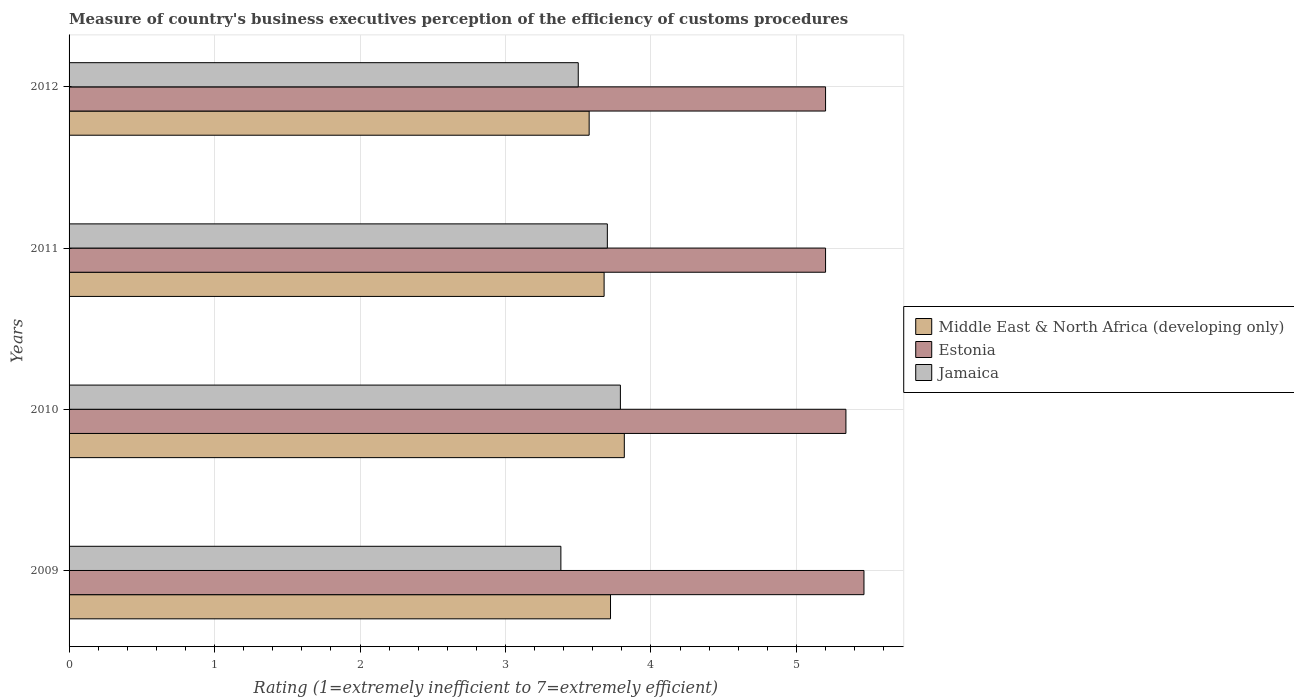How many different coloured bars are there?
Your answer should be compact. 3. How many groups of bars are there?
Provide a succinct answer. 4. Are the number of bars per tick equal to the number of legend labels?
Make the answer very short. Yes. How many bars are there on the 1st tick from the bottom?
Your response must be concise. 3. What is the rating of the efficiency of customs procedure in Jamaica in 2011?
Provide a short and direct response. 3.7. Across all years, what is the maximum rating of the efficiency of customs procedure in Jamaica?
Your answer should be very brief. 3.79. Across all years, what is the minimum rating of the efficiency of customs procedure in Estonia?
Keep it short and to the point. 5.2. In which year was the rating of the efficiency of customs procedure in Middle East & North Africa (developing only) maximum?
Your answer should be very brief. 2010. What is the total rating of the efficiency of customs procedure in Middle East & North Africa (developing only) in the graph?
Give a very brief answer. 14.79. What is the difference between the rating of the efficiency of customs procedure in Estonia in 2010 and that in 2012?
Make the answer very short. 0.14. What is the difference between the rating of the efficiency of customs procedure in Estonia in 2010 and the rating of the efficiency of customs procedure in Middle East & North Africa (developing only) in 2009?
Offer a terse response. 1.62. What is the average rating of the efficiency of customs procedure in Middle East & North Africa (developing only) per year?
Give a very brief answer. 3.7. In the year 2009, what is the difference between the rating of the efficiency of customs procedure in Middle East & North Africa (developing only) and rating of the efficiency of customs procedure in Estonia?
Your answer should be compact. -1.74. In how many years, is the rating of the efficiency of customs procedure in Middle East & North Africa (developing only) greater than 1.2 ?
Provide a short and direct response. 4. What is the ratio of the rating of the efficiency of customs procedure in Middle East & North Africa (developing only) in 2011 to that in 2012?
Make the answer very short. 1.03. What is the difference between the highest and the second highest rating of the efficiency of customs procedure in Middle East & North Africa (developing only)?
Your answer should be very brief. 0.09. What is the difference between the highest and the lowest rating of the efficiency of customs procedure in Jamaica?
Make the answer very short. 0.41. What does the 3rd bar from the top in 2011 represents?
Provide a short and direct response. Middle East & North Africa (developing only). What does the 2nd bar from the bottom in 2011 represents?
Make the answer very short. Estonia. How many bars are there?
Ensure brevity in your answer.  12. Are all the bars in the graph horizontal?
Give a very brief answer. Yes. What is the difference between two consecutive major ticks on the X-axis?
Provide a succinct answer. 1. Does the graph contain any zero values?
Offer a terse response. No. Where does the legend appear in the graph?
Your answer should be very brief. Center right. How many legend labels are there?
Keep it short and to the point. 3. What is the title of the graph?
Your answer should be compact. Measure of country's business executives perception of the efficiency of customs procedures. Does "Ethiopia" appear as one of the legend labels in the graph?
Provide a short and direct response. No. What is the label or title of the X-axis?
Give a very brief answer. Rating (1=extremely inefficient to 7=extremely efficient). What is the label or title of the Y-axis?
Offer a very short reply. Years. What is the Rating (1=extremely inefficient to 7=extremely efficient) in Middle East & North Africa (developing only) in 2009?
Provide a succinct answer. 3.72. What is the Rating (1=extremely inefficient to 7=extremely efficient) in Estonia in 2009?
Your answer should be compact. 5.46. What is the Rating (1=extremely inefficient to 7=extremely efficient) in Jamaica in 2009?
Provide a short and direct response. 3.38. What is the Rating (1=extremely inefficient to 7=extremely efficient) of Middle East & North Africa (developing only) in 2010?
Offer a terse response. 3.82. What is the Rating (1=extremely inefficient to 7=extremely efficient) in Estonia in 2010?
Offer a very short reply. 5.34. What is the Rating (1=extremely inefficient to 7=extremely efficient) of Jamaica in 2010?
Offer a very short reply. 3.79. What is the Rating (1=extremely inefficient to 7=extremely efficient) in Middle East & North Africa (developing only) in 2011?
Make the answer very short. 3.68. What is the Rating (1=extremely inefficient to 7=extremely efficient) of Estonia in 2011?
Your answer should be compact. 5.2. What is the Rating (1=extremely inefficient to 7=extremely efficient) in Middle East & North Africa (developing only) in 2012?
Ensure brevity in your answer.  3.58. What is the Rating (1=extremely inefficient to 7=extremely efficient) in Estonia in 2012?
Make the answer very short. 5.2. Across all years, what is the maximum Rating (1=extremely inefficient to 7=extremely efficient) of Middle East & North Africa (developing only)?
Your answer should be compact. 3.82. Across all years, what is the maximum Rating (1=extremely inefficient to 7=extremely efficient) of Estonia?
Offer a terse response. 5.46. Across all years, what is the maximum Rating (1=extremely inefficient to 7=extremely efficient) in Jamaica?
Make the answer very short. 3.79. Across all years, what is the minimum Rating (1=extremely inefficient to 7=extremely efficient) of Middle East & North Africa (developing only)?
Your answer should be compact. 3.58. Across all years, what is the minimum Rating (1=extremely inefficient to 7=extremely efficient) in Jamaica?
Provide a short and direct response. 3.38. What is the total Rating (1=extremely inefficient to 7=extremely efficient) of Middle East & North Africa (developing only) in the graph?
Give a very brief answer. 14.79. What is the total Rating (1=extremely inefficient to 7=extremely efficient) in Estonia in the graph?
Your response must be concise. 21.2. What is the total Rating (1=extremely inefficient to 7=extremely efficient) in Jamaica in the graph?
Your answer should be compact. 14.37. What is the difference between the Rating (1=extremely inefficient to 7=extremely efficient) of Middle East & North Africa (developing only) in 2009 and that in 2010?
Your answer should be very brief. -0.09. What is the difference between the Rating (1=extremely inefficient to 7=extremely efficient) in Estonia in 2009 and that in 2010?
Make the answer very short. 0.12. What is the difference between the Rating (1=extremely inefficient to 7=extremely efficient) of Jamaica in 2009 and that in 2010?
Keep it short and to the point. -0.41. What is the difference between the Rating (1=extremely inefficient to 7=extremely efficient) in Middle East & North Africa (developing only) in 2009 and that in 2011?
Offer a very short reply. 0.04. What is the difference between the Rating (1=extremely inefficient to 7=extremely efficient) in Estonia in 2009 and that in 2011?
Give a very brief answer. 0.26. What is the difference between the Rating (1=extremely inefficient to 7=extremely efficient) in Jamaica in 2009 and that in 2011?
Offer a terse response. -0.32. What is the difference between the Rating (1=extremely inefficient to 7=extremely efficient) of Middle East & North Africa (developing only) in 2009 and that in 2012?
Your response must be concise. 0.15. What is the difference between the Rating (1=extremely inefficient to 7=extremely efficient) of Estonia in 2009 and that in 2012?
Your answer should be compact. 0.26. What is the difference between the Rating (1=extremely inefficient to 7=extremely efficient) in Jamaica in 2009 and that in 2012?
Keep it short and to the point. -0.12. What is the difference between the Rating (1=extremely inefficient to 7=extremely efficient) in Middle East & North Africa (developing only) in 2010 and that in 2011?
Offer a terse response. 0.14. What is the difference between the Rating (1=extremely inefficient to 7=extremely efficient) of Estonia in 2010 and that in 2011?
Keep it short and to the point. 0.14. What is the difference between the Rating (1=extremely inefficient to 7=extremely efficient) in Jamaica in 2010 and that in 2011?
Offer a very short reply. 0.09. What is the difference between the Rating (1=extremely inefficient to 7=extremely efficient) in Middle East & North Africa (developing only) in 2010 and that in 2012?
Your answer should be very brief. 0.24. What is the difference between the Rating (1=extremely inefficient to 7=extremely efficient) in Estonia in 2010 and that in 2012?
Provide a short and direct response. 0.14. What is the difference between the Rating (1=extremely inefficient to 7=extremely efficient) in Jamaica in 2010 and that in 2012?
Your answer should be compact. 0.29. What is the difference between the Rating (1=extremely inefficient to 7=extremely efficient) in Middle East & North Africa (developing only) in 2011 and that in 2012?
Provide a succinct answer. 0.1. What is the difference between the Rating (1=extremely inefficient to 7=extremely efficient) in Estonia in 2011 and that in 2012?
Your answer should be very brief. 0. What is the difference between the Rating (1=extremely inefficient to 7=extremely efficient) in Jamaica in 2011 and that in 2012?
Offer a terse response. 0.2. What is the difference between the Rating (1=extremely inefficient to 7=extremely efficient) of Middle East & North Africa (developing only) in 2009 and the Rating (1=extremely inefficient to 7=extremely efficient) of Estonia in 2010?
Make the answer very short. -1.62. What is the difference between the Rating (1=extremely inefficient to 7=extremely efficient) in Middle East & North Africa (developing only) in 2009 and the Rating (1=extremely inefficient to 7=extremely efficient) in Jamaica in 2010?
Your answer should be compact. -0.07. What is the difference between the Rating (1=extremely inefficient to 7=extremely efficient) of Estonia in 2009 and the Rating (1=extremely inefficient to 7=extremely efficient) of Jamaica in 2010?
Keep it short and to the point. 1.67. What is the difference between the Rating (1=extremely inefficient to 7=extremely efficient) of Middle East & North Africa (developing only) in 2009 and the Rating (1=extremely inefficient to 7=extremely efficient) of Estonia in 2011?
Make the answer very short. -1.48. What is the difference between the Rating (1=extremely inefficient to 7=extremely efficient) in Middle East & North Africa (developing only) in 2009 and the Rating (1=extremely inefficient to 7=extremely efficient) in Jamaica in 2011?
Your answer should be very brief. 0.02. What is the difference between the Rating (1=extremely inefficient to 7=extremely efficient) in Estonia in 2009 and the Rating (1=extremely inefficient to 7=extremely efficient) in Jamaica in 2011?
Give a very brief answer. 1.76. What is the difference between the Rating (1=extremely inefficient to 7=extremely efficient) in Middle East & North Africa (developing only) in 2009 and the Rating (1=extremely inefficient to 7=extremely efficient) in Estonia in 2012?
Make the answer very short. -1.48. What is the difference between the Rating (1=extremely inefficient to 7=extremely efficient) in Middle East & North Africa (developing only) in 2009 and the Rating (1=extremely inefficient to 7=extremely efficient) in Jamaica in 2012?
Offer a very short reply. 0.22. What is the difference between the Rating (1=extremely inefficient to 7=extremely efficient) of Estonia in 2009 and the Rating (1=extremely inefficient to 7=extremely efficient) of Jamaica in 2012?
Your response must be concise. 1.96. What is the difference between the Rating (1=extremely inefficient to 7=extremely efficient) in Middle East & North Africa (developing only) in 2010 and the Rating (1=extremely inefficient to 7=extremely efficient) in Estonia in 2011?
Your answer should be very brief. -1.38. What is the difference between the Rating (1=extremely inefficient to 7=extremely efficient) of Middle East & North Africa (developing only) in 2010 and the Rating (1=extremely inefficient to 7=extremely efficient) of Jamaica in 2011?
Your answer should be compact. 0.12. What is the difference between the Rating (1=extremely inefficient to 7=extremely efficient) of Estonia in 2010 and the Rating (1=extremely inefficient to 7=extremely efficient) of Jamaica in 2011?
Offer a very short reply. 1.64. What is the difference between the Rating (1=extremely inefficient to 7=extremely efficient) of Middle East & North Africa (developing only) in 2010 and the Rating (1=extremely inefficient to 7=extremely efficient) of Estonia in 2012?
Your response must be concise. -1.38. What is the difference between the Rating (1=extremely inefficient to 7=extremely efficient) in Middle East & North Africa (developing only) in 2010 and the Rating (1=extremely inefficient to 7=extremely efficient) in Jamaica in 2012?
Your response must be concise. 0.32. What is the difference between the Rating (1=extremely inefficient to 7=extremely efficient) in Estonia in 2010 and the Rating (1=extremely inefficient to 7=extremely efficient) in Jamaica in 2012?
Offer a terse response. 1.84. What is the difference between the Rating (1=extremely inefficient to 7=extremely efficient) of Middle East & North Africa (developing only) in 2011 and the Rating (1=extremely inefficient to 7=extremely efficient) of Estonia in 2012?
Your answer should be very brief. -1.52. What is the difference between the Rating (1=extremely inefficient to 7=extremely efficient) in Middle East & North Africa (developing only) in 2011 and the Rating (1=extremely inefficient to 7=extremely efficient) in Jamaica in 2012?
Provide a succinct answer. 0.18. What is the difference between the Rating (1=extremely inefficient to 7=extremely efficient) of Estonia in 2011 and the Rating (1=extremely inefficient to 7=extremely efficient) of Jamaica in 2012?
Provide a short and direct response. 1.7. What is the average Rating (1=extremely inefficient to 7=extremely efficient) in Middle East & North Africa (developing only) per year?
Ensure brevity in your answer.  3.7. What is the average Rating (1=extremely inefficient to 7=extremely efficient) in Estonia per year?
Give a very brief answer. 5.3. What is the average Rating (1=extremely inefficient to 7=extremely efficient) of Jamaica per year?
Your answer should be compact. 3.59. In the year 2009, what is the difference between the Rating (1=extremely inefficient to 7=extremely efficient) in Middle East & North Africa (developing only) and Rating (1=extremely inefficient to 7=extremely efficient) in Estonia?
Offer a very short reply. -1.74. In the year 2009, what is the difference between the Rating (1=extremely inefficient to 7=extremely efficient) in Middle East & North Africa (developing only) and Rating (1=extremely inefficient to 7=extremely efficient) in Jamaica?
Keep it short and to the point. 0.34. In the year 2009, what is the difference between the Rating (1=extremely inefficient to 7=extremely efficient) of Estonia and Rating (1=extremely inefficient to 7=extremely efficient) of Jamaica?
Keep it short and to the point. 2.08. In the year 2010, what is the difference between the Rating (1=extremely inefficient to 7=extremely efficient) in Middle East & North Africa (developing only) and Rating (1=extremely inefficient to 7=extremely efficient) in Estonia?
Keep it short and to the point. -1.52. In the year 2010, what is the difference between the Rating (1=extremely inefficient to 7=extremely efficient) of Middle East & North Africa (developing only) and Rating (1=extremely inefficient to 7=extremely efficient) of Jamaica?
Your answer should be compact. 0.03. In the year 2010, what is the difference between the Rating (1=extremely inefficient to 7=extremely efficient) in Estonia and Rating (1=extremely inefficient to 7=extremely efficient) in Jamaica?
Provide a succinct answer. 1.55. In the year 2011, what is the difference between the Rating (1=extremely inefficient to 7=extremely efficient) of Middle East & North Africa (developing only) and Rating (1=extremely inefficient to 7=extremely efficient) of Estonia?
Make the answer very short. -1.52. In the year 2011, what is the difference between the Rating (1=extremely inefficient to 7=extremely efficient) of Middle East & North Africa (developing only) and Rating (1=extremely inefficient to 7=extremely efficient) of Jamaica?
Offer a terse response. -0.02. In the year 2012, what is the difference between the Rating (1=extremely inefficient to 7=extremely efficient) of Middle East & North Africa (developing only) and Rating (1=extremely inefficient to 7=extremely efficient) of Estonia?
Your answer should be compact. -1.62. In the year 2012, what is the difference between the Rating (1=extremely inefficient to 7=extremely efficient) of Middle East & North Africa (developing only) and Rating (1=extremely inefficient to 7=extremely efficient) of Jamaica?
Your answer should be very brief. 0.07. In the year 2012, what is the difference between the Rating (1=extremely inefficient to 7=extremely efficient) in Estonia and Rating (1=extremely inefficient to 7=extremely efficient) in Jamaica?
Your answer should be compact. 1.7. What is the ratio of the Rating (1=extremely inefficient to 7=extremely efficient) of Middle East & North Africa (developing only) in 2009 to that in 2010?
Your response must be concise. 0.98. What is the ratio of the Rating (1=extremely inefficient to 7=extremely efficient) in Estonia in 2009 to that in 2010?
Keep it short and to the point. 1.02. What is the ratio of the Rating (1=extremely inefficient to 7=extremely efficient) in Jamaica in 2009 to that in 2010?
Provide a short and direct response. 0.89. What is the ratio of the Rating (1=extremely inefficient to 7=extremely efficient) in Estonia in 2009 to that in 2011?
Provide a succinct answer. 1.05. What is the ratio of the Rating (1=extremely inefficient to 7=extremely efficient) of Jamaica in 2009 to that in 2011?
Provide a short and direct response. 0.91. What is the ratio of the Rating (1=extremely inefficient to 7=extremely efficient) in Middle East & North Africa (developing only) in 2009 to that in 2012?
Provide a succinct answer. 1.04. What is the ratio of the Rating (1=extremely inefficient to 7=extremely efficient) in Estonia in 2009 to that in 2012?
Your answer should be very brief. 1.05. What is the ratio of the Rating (1=extremely inefficient to 7=extremely efficient) of Jamaica in 2009 to that in 2012?
Give a very brief answer. 0.97. What is the ratio of the Rating (1=extremely inefficient to 7=extremely efficient) in Middle East & North Africa (developing only) in 2010 to that in 2011?
Provide a succinct answer. 1.04. What is the ratio of the Rating (1=extremely inefficient to 7=extremely efficient) in Estonia in 2010 to that in 2011?
Your answer should be very brief. 1.03. What is the ratio of the Rating (1=extremely inefficient to 7=extremely efficient) of Jamaica in 2010 to that in 2011?
Give a very brief answer. 1.02. What is the ratio of the Rating (1=extremely inefficient to 7=extremely efficient) in Middle East & North Africa (developing only) in 2010 to that in 2012?
Your answer should be compact. 1.07. What is the ratio of the Rating (1=extremely inefficient to 7=extremely efficient) in Estonia in 2010 to that in 2012?
Provide a succinct answer. 1.03. What is the ratio of the Rating (1=extremely inefficient to 7=extremely efficient) in Jamaica in 2010 to that in 2012?
Offer a very short reply. 1.08. What is the ratio of the Rating (1=extremely inefficient to 7=extremely efficient) of Middle East & North Africa (developing only) in 2011 to that in 2012?
Make the answer very short. 1.03. What is the ratio of the Rating (1=extremely inefficient to 7=extremely efficient) in Jamaica in 2011 to that in 2012?
Offer a very short reply. 1.06. What is the difference between the highest and the second highest Rating (1=extremely inefficient to 7=extremely efficient) of Middle East & North Africa (developing only)?
Your response must be concise. 0.09. What is the difference between the highest and the second highest Rating (1=extremely inefficient to 7=extremely efficient) of Estonia?
Ensure brevity in your answer.  0.12. What is the difference between the highest and the second highest Rating (1=extremely inefficient to 7=extremely efficient) in Jamaica?
Provide a succinct answer. 0.09. What is the difference between the highest and the lowest Rating (1=extremely inefficient to 7=extremely efficient) of Middle East & North Africa (developing only)?
Provide a succinct answer. 0.24. What is the difference between the highest and the lowest Rating (1=extremely inefficient to 7=extremely efficient) in Estonia?
Give a very brief answer. 0.26. What is the difference between the highest and the lowest Rating (1=extremely inefficient to 7=extremely efficient) in Jamaica?
Provide a short and direct response. 0.41. 